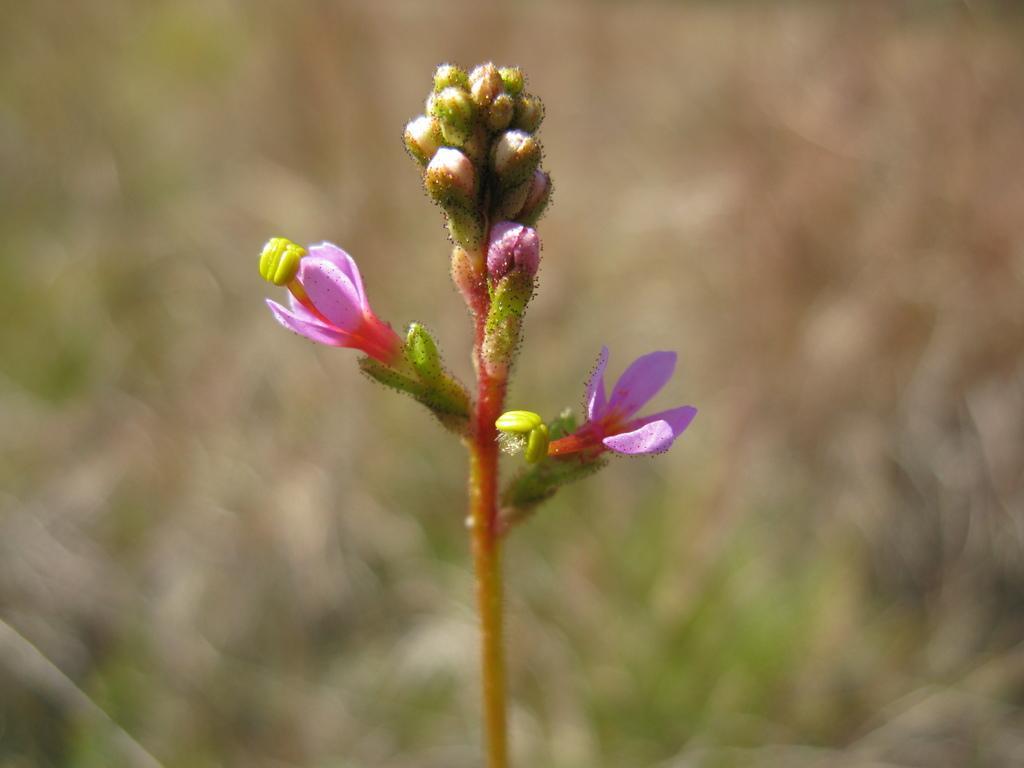Describe this image in one or two sentences. In this image in the foreground there are flowers and stem, and the background is blurred. 